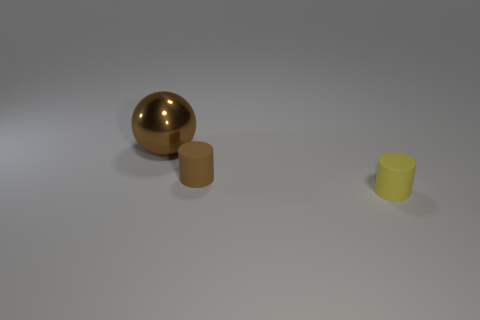Add 3 large blue objects. How many objects exist? 6 Subtract all cylinders. How many objects are left? 1 Add 3 tiny matte objects. How many tiny matte objects are left? 5 Add 3 matte objects. How many matte objects exist? 5 Subtract 0 cyan cylinders. How many objects are left? 3 Subtract all spheres. Subtract all cyan rubber things. How many objects are left? 2 